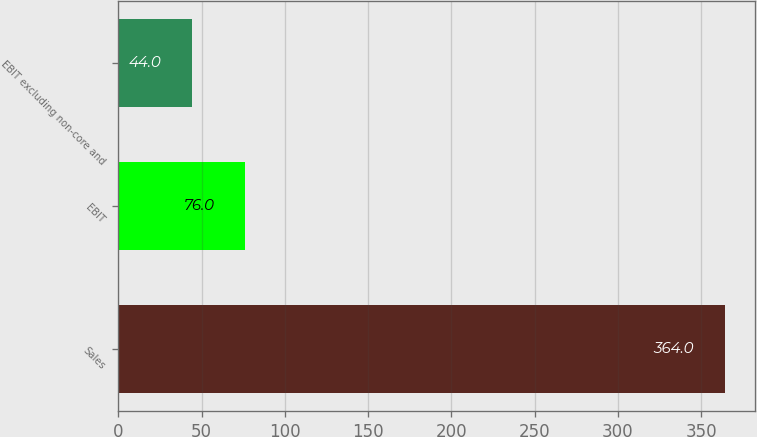Convert chart. <chart><loc_0><loc_0><loc_500><loc_500><bar_chart><fcel>Sales<fcel>EBIT<fcel>EBIT excluding non-core and<nl><fcel>364<fcel>76<fcel>44<nl></chart> 